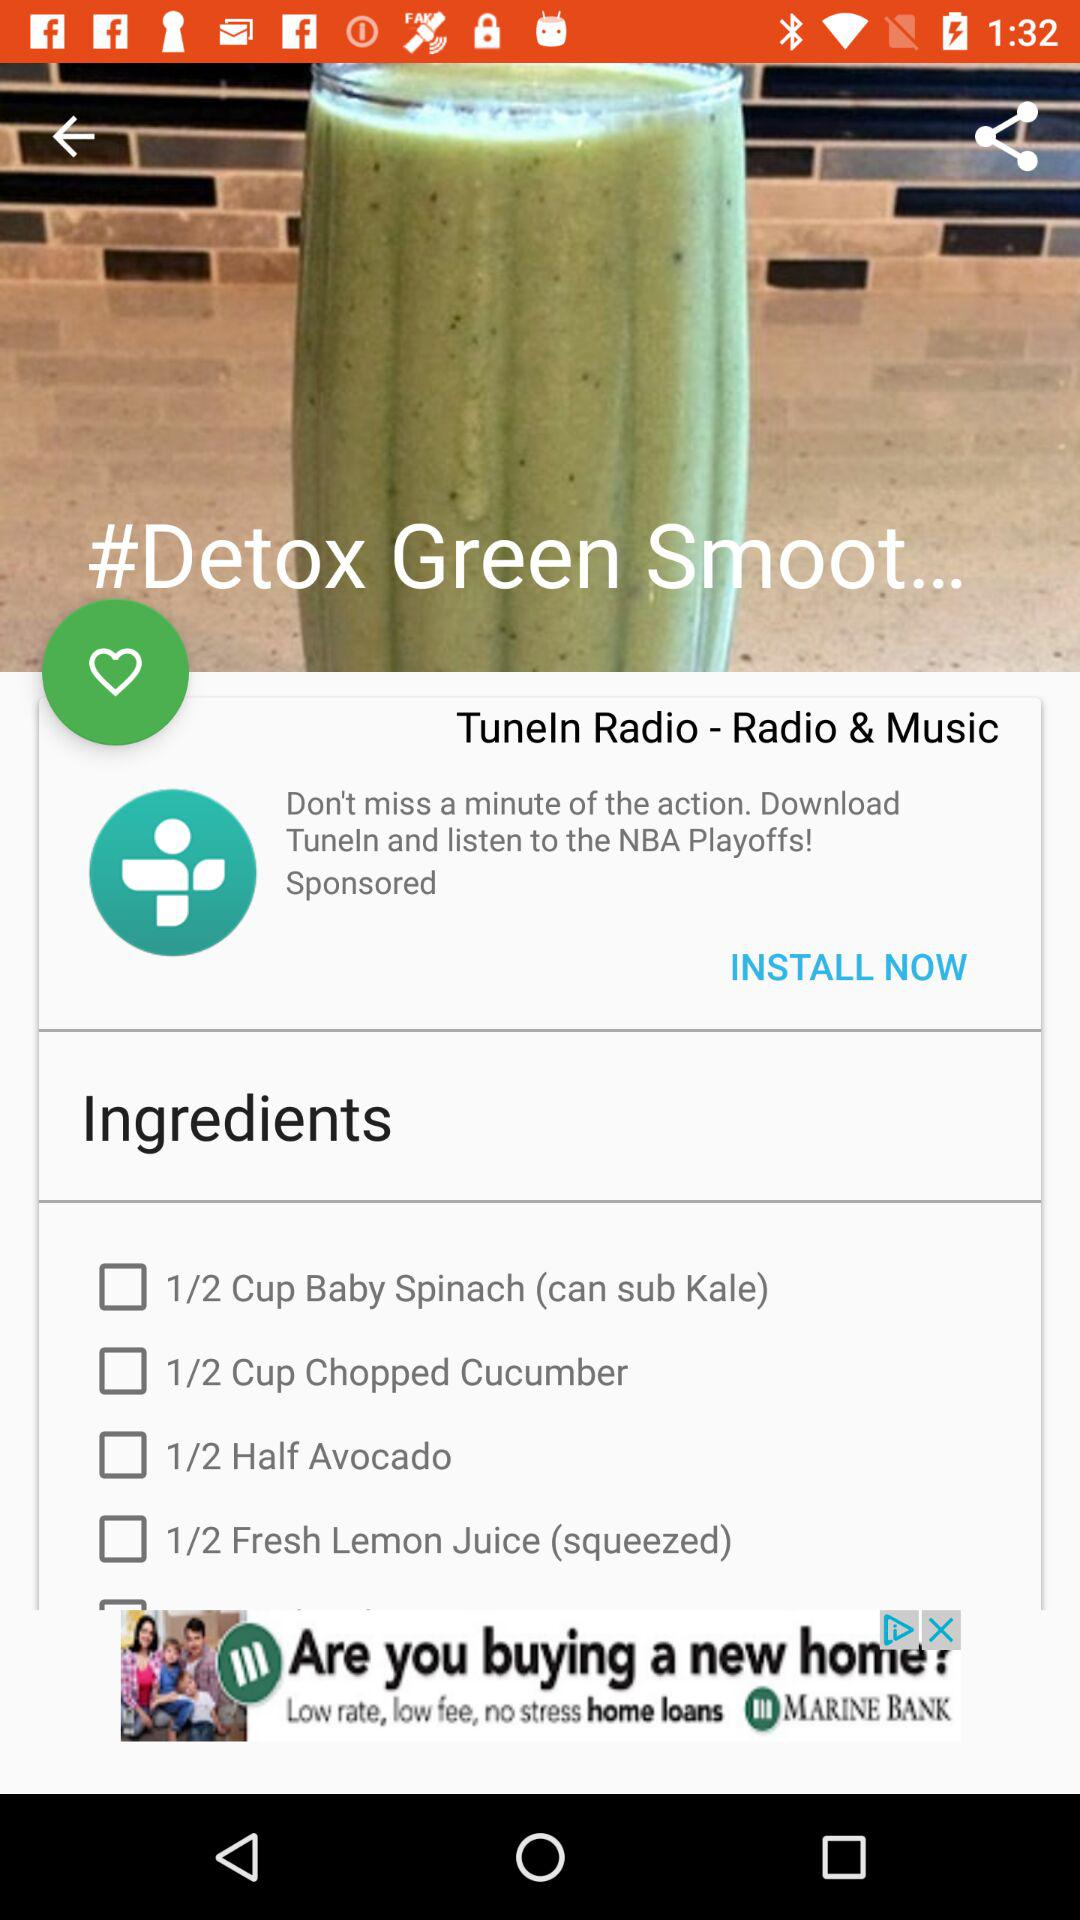What are the ingredients? The ingredients are "Baby Spinach", "Chopped Cucumber", "Avocado" and "Fresh Lemon Juice". 